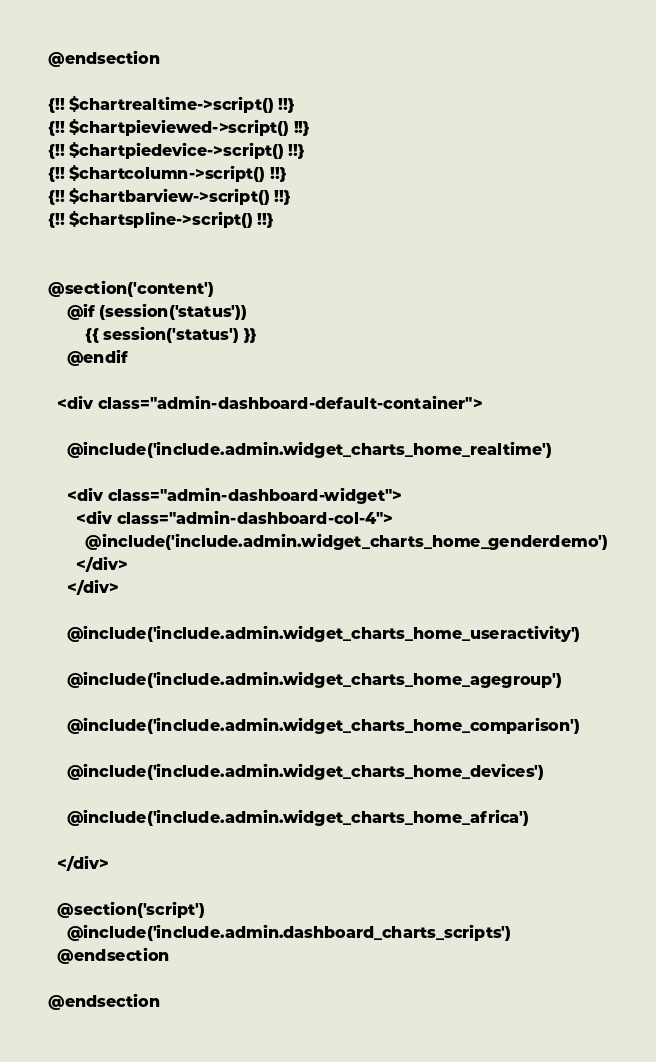<code> <loc_0><loc_0><loc_500><loc_500><_PHP_>@endsection

{!! $chartrealtime->script() !!}
{!! $chartpieviewed->script() !!}
{!! $chartpiedevice->script() !!}
{!! $chartcolumn->script() !!}
{!! $chartbarview->script() !!}
{!! $chartspline->script() !!}


@section('content')
	@if (session('status'))
		{{ session('status') }}
	@endif

  <div class="admin-dashboard-default-container"> 

    @include('include.admin.widget_charts_home_realtime')

    <div class="admin-dashboard-widget">
      <div class="admin-dashboard-col-4"> 
        @include('include.admin.widget_charts_home_genderdemo')
      </div>
    </div>

    @include('include.admin.widget_charts_home_useractivity')

    @include('include.admin.widget_charts_home_agegroup')

    @include('include.admin.widget_charts_home_comparison')

    @include('include.admin.widget_charts_home_devices')

    @include('include.admin.widget_charts_home_africa')

  </div>   

  @section('script')
    @include('include.admin.dashboard_charts_scripts')
  @endsection

@endsection</code> 